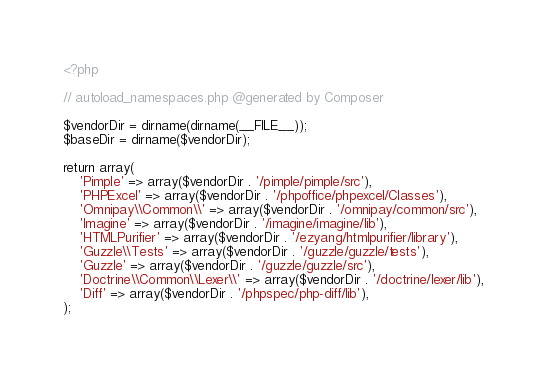<code> <loc_0><loc_0><loc_500><loc_500><_PHP_><?php

// autoload_namespaces.php @generated by Composer

$vendorDir = dirname(dirname(__FILE__));
$baseDir = dirname($vendorDir);

return array(
    'Pimple' => array($vendorDir . '/pimple/pimple/src'),
    'PHPExcel' => array($vendorDir . '/phpoffice/phpexcel/Classes'),
    'Omnipay\\Common\\' => array($vendorDir . '/omnipay/common/src'),
    'Imagine' => array($vendorDir . '/imagine/imagine/lib'),
    'HTMLPurifier' => array($vendorDir . '/ezyang/htmlpurifier/library'),
    'Guzzle\\Tests' => array($vendorDir . '/guzzle/guzzle/tests'),
    'Guzzle' => array($vendorDir . '/guzzle/guzzle/src'),
    'Doctrine\\Common\\Lexer\\' => array($vendorDir . '/doctrine/lexer/lib'),
    'Diff' => array($vendorDir . '/phpspec/php-diff/lib'),
);
</code> 